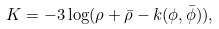<formula> <loc_0><loc_0><loc_500><loc_500>K = - 3 \log ( \rho + \bar { \rho } - k ( \phi , \bar { \phi } ) ) ,</formula> 